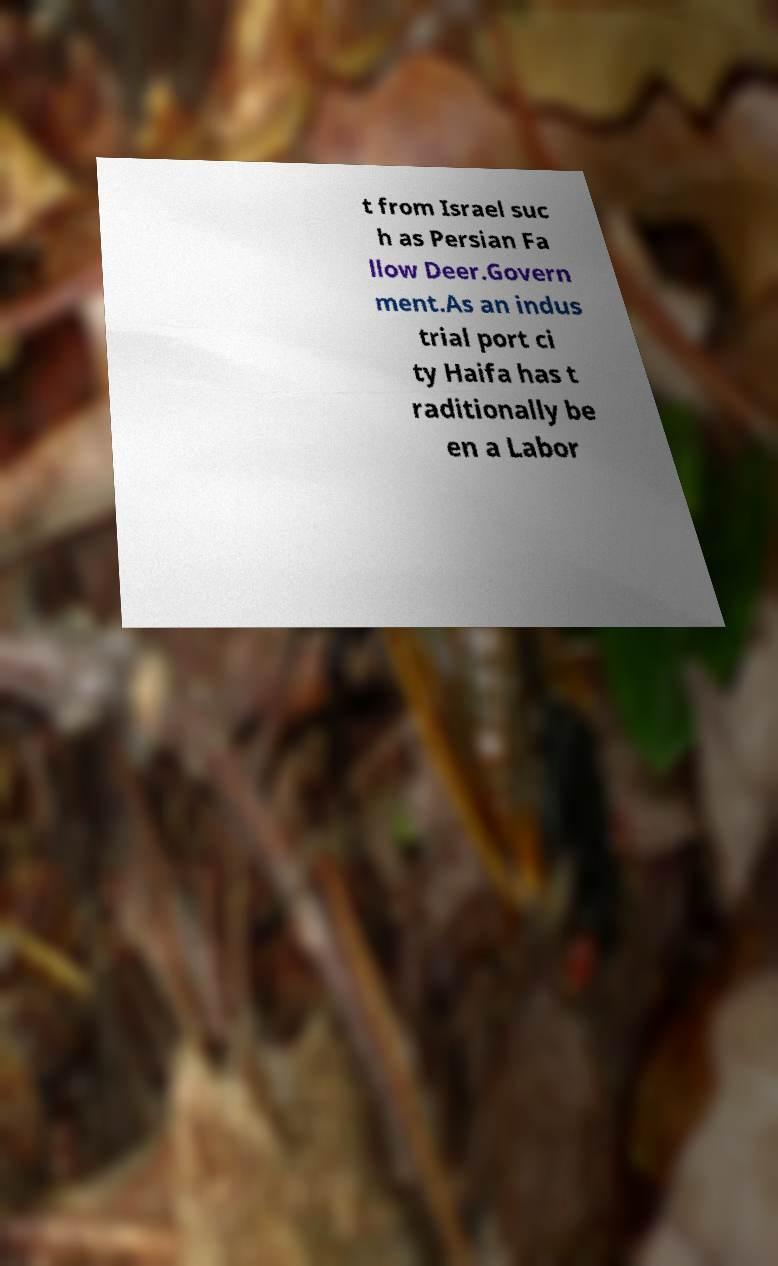Can you accurately transcribe the text from the provided image for me? t from Israel suc h as Persian Fa llow Deer.Govern ment.As an indus trial port ci ty Haifa has t raditionally be en a Labor 